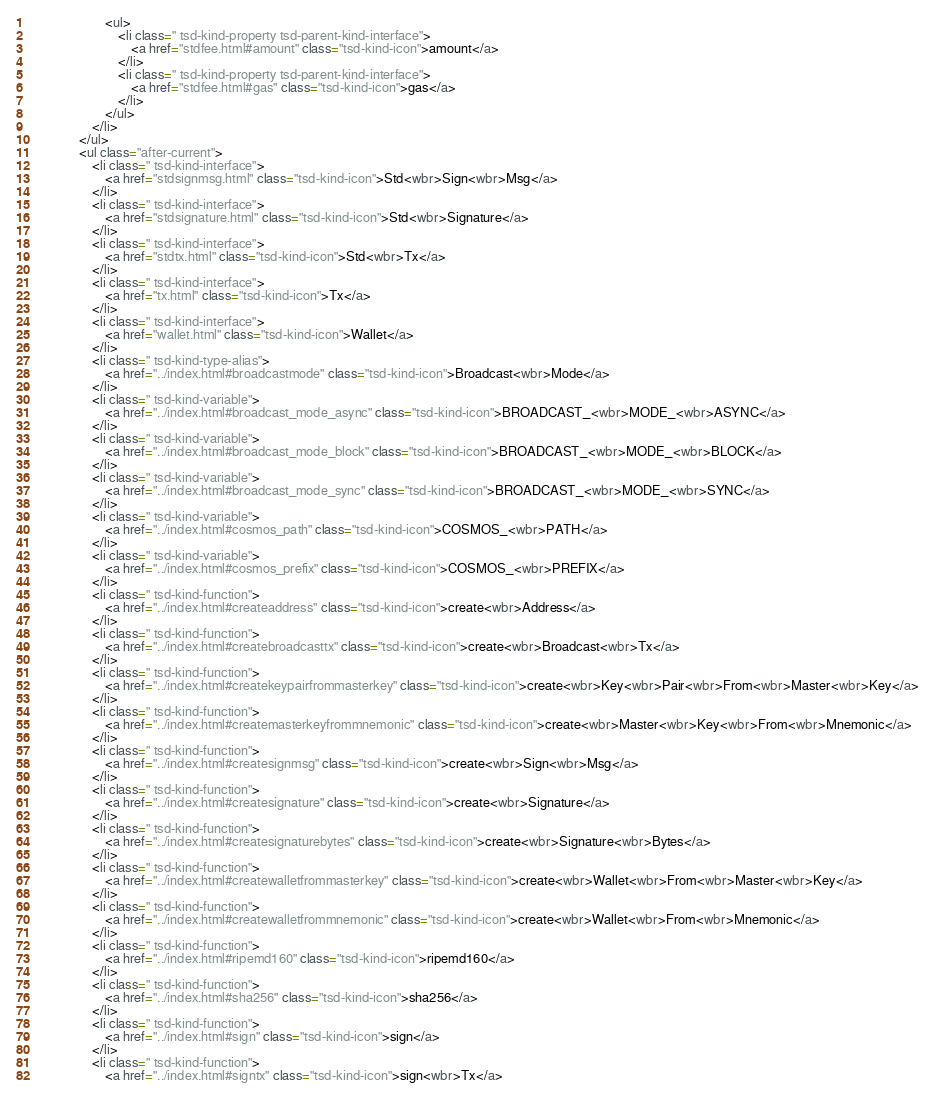<code> <loc_0><loc_0><loc_500><loc_500><_HTML_>						<ul>
							<li class=" tsd-kind-property tsd-parent-kind-interface">
								<a href="stdfee.html#amount" class="tsd-kind-icon">amount</a>
							</li>
							<li class=" tsd-kind-property tsd-parent-kind-interface">
								<a href="stdfee.html#gas" class="tsd-kind-icon">gas</a>
							</li>
						</ul>
					</li>
				</ul>
				<ul class="after-current">
					<li class=" tsd-kind-interface">
						<a href="stdsignmsg.html" class="tsd-kind-icon">Std<wbr>Sign<wbr>Msg</a>
					</li>
					<li class=" tsd-kind-interface">
						<a href="stdsignature.html" class="tsd-kind-icon">Std<wbr>Signature</a>
					</li>
					<li class=" tsd-kind-interface">
						<a href="stdtx.html" class="tsd-kind-icon">Std<wbr>Tx</a>
					</li>
					<li class=" tsd-kind-interface">
						<a href="tx.html" class="tsd-kind-icon">Tx</a>
					</li>
					<li class=" tsd-kind-interface">
						<a href="wallet.html" class="tsd-kind-icon">Wallet</a>
					</li>
					<li class=" tsd-kind-type-alias">
						<a href="../index.html#broadcastmode" class="tsd-kind-icon">Broadcast<wbr>Mode</a>
					</li>
					<li class=" tsd-kind-variable">
						<a href="../index.html#broadcast_mode_async" class="tsd-kind-icon">BROADCAST_<wbr>MODE_<wbr>ASYNC</a>
					</li>
					<li class=" tsd-kind-variable">
						<a href="../index.html#broadcast_mode_block" class="tsd-kind-icon">BROADCAST_<wbr>MODE_<wbr>BLOCK</a>
					</li>
					<li class=" tsd-kind-variable">
						<a href="../index.html#broadcast_mode_sync" class="tsd-kind-icon">BROADCAST_<wbr>MODE_<wbr>SYNC</a>
					</li>
					<li class=" tsd-kind-variable">
						<a href="../index.html#cosmos_path" class="tsd-kind-icon">COSMOS_<wbr>PATH</a>
					</li>
					<li class=" tsd-kind-variable">
						<a href="../index.html#cosmos_prefix" class="tsd-kind-icon">COSMOS_<wbr>PREFIX</a>
					</li>
					<li class=" tsd-kind-function">
						<a href="../index.html#createaddress" class="tsd-kind-icon">create<wbr>Address</a>
					</li>
					<li class=" tsd-kind-function">
						<a href="../index.html#createbroadcasttx" class="tsd-kind-icon">create<wbr>Broadcast<wbr>Tx</a>
					</li>
					<li class=" tsd-kind-function">
						<a href="../index.html#createkeypairfrommasterkey" class="tsd-kind-icon">create<wbr>Key<wbr>Pair<wbr>From<wbr>Master<wbr>Key</a>
					</li>
					<li class=" tsd-kind-function">
						<a href="../index.html#createmasterkeyfrommnemonic" class="tsd-kind-icon">create<wbr>Master<wbr>Key<wbr>From<wbr>Mnemonic</a>
					</li>
					<li class=" tsd-kind-function">
						<a href="../index.html#createsignmsg" class="tsd-kind-icon">create<wbr>Sign<wbr>Msg</a>
					</li>
					<li class=" tsd-kind-function">
						<a href="../index.html#createsignature" class="tsd-kind-icon">create<wbr>Signature</a>
					</li>
					<li class=" tsd-kind-function">
						<a href="../index.html#createsignaturebytes" class="tsd-kind-icon">create<wbr>Signature<wbr>Bytes</a>
					</li>
					<li class=" tsd-kind-function">
						<a href="../index.html#createwalletfrommasterkey" class="tsd-kind-icon">create<wbr>Wallet<wbr>From<wbr>Master<wbr>Key</a>
					</li>
					<li class=" tsd-kind-function">
						<a href="../index.html#createwalletfrommnemonic" class="tsd-kind-icon">create<wbr>Wallet<wbr>From<wbr>Mnemonic</a>
					</li>
					<li class=" tsd-kind-function">
						<a href="../index.html#ripemd160" class="tsd-kind-icon">ripemd160</a>
					</li>
					<li class=" tsd-kind-function">
						<a href="../index.html#sha256" class="tsd-kind-icon">sha256</a>
					</li>
					<li class=" tsd-kind-function">
						<a href="../index.html#sign" class="tsd-kind-icon">sign</a>
					</li>
					<li class=" tsd-kind-function">
						<a href="../index.html#signtx" class="tsd-kind-icon">sign<wbr>Tx</a></code> 